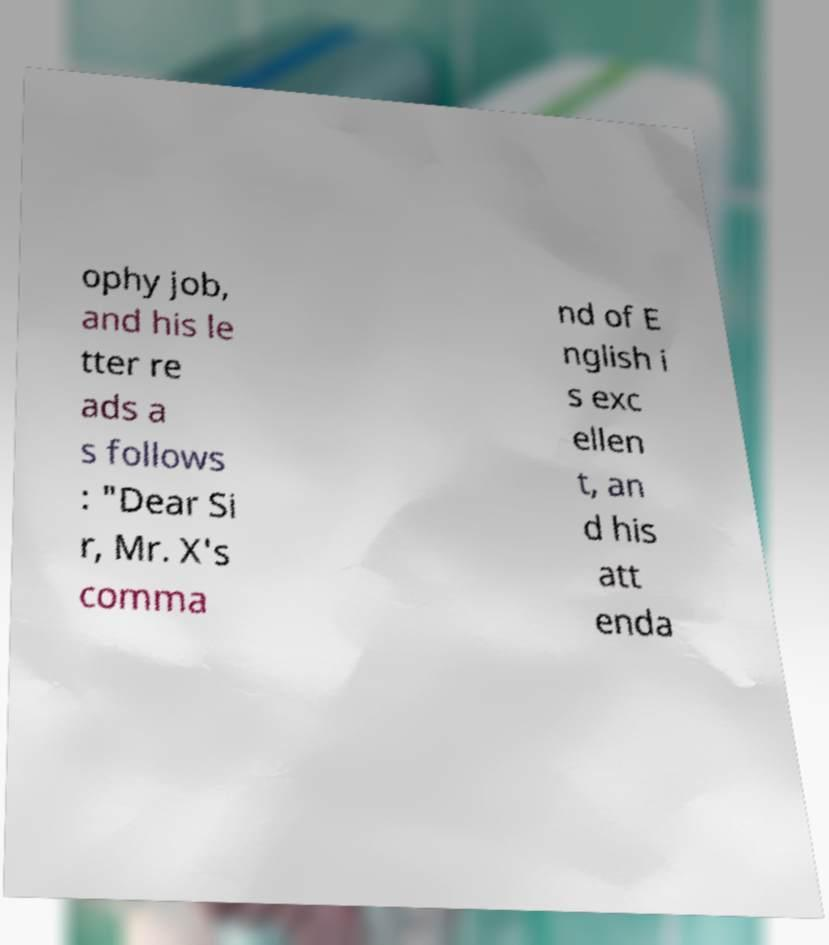What messages or text are displayed in this image? I need them in a readable, typed format. ophy job, and his le tter re ads a s follows : "Dear Si r, Mr. X's comma nd of E nglish i s exc ellen t, an d his att enda 